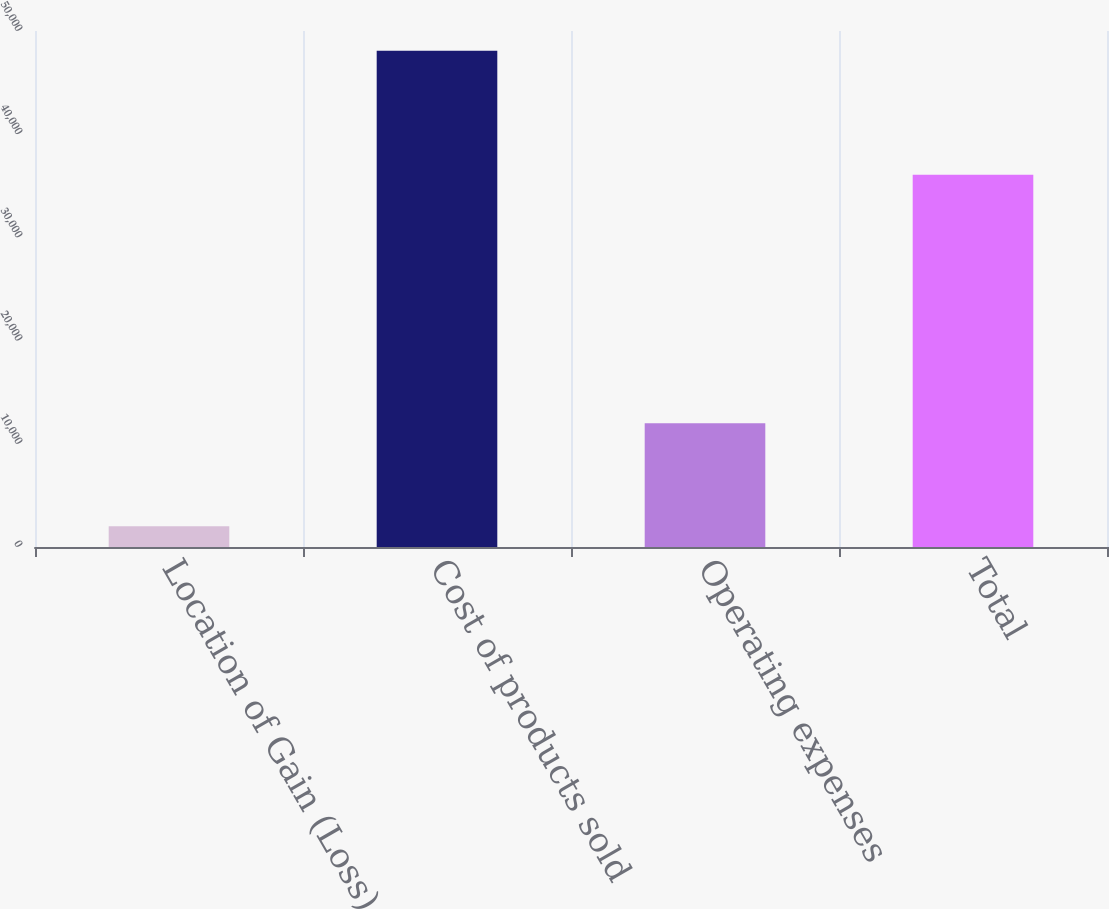Convert chart. <chart><loc_0><loc_0><loc_500><loc_500><bar_chart><fcel>Location of Gain (Loss)<fcel>Cost of products sold<fcel>Operating expenses<fcel>Total<nl><fcel>2015<fcel>48082<fcel>12003<fcel>36079<nl></chart> 